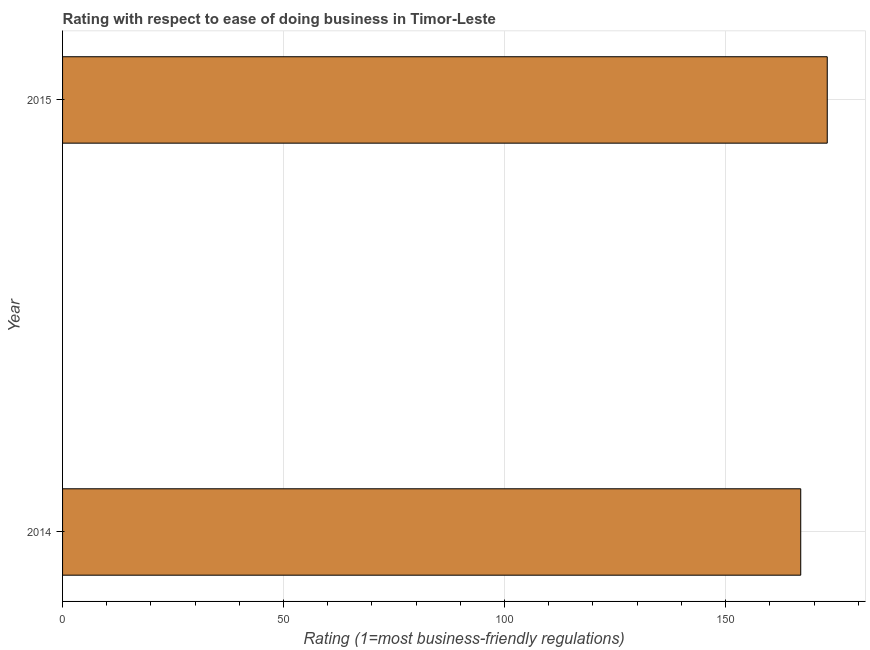Does the graph contain any zero values?
Offer a very short reply. No. Does the graph contain grids?
Give a very brief answer. Yes. What is the title of the graph?
Your response must be concise. Rating with respect to ease of doing business in Timor-Leste. What is the label or title of the X-axis?
Your answer should be very brief. Rating (1=most business-friendly regulations). What is the label or title of the Y-axis?
Your answer should be compact. Year. What is the ease of doing business index in 2014?
Offer a very short reply. 167. Across all years, what is the maximum ease of doing business index?
Offer a very short reply. 173. Across all years, what is the minimum ease of doing business index?
Provide a succinct answer. 167. In which year was the ease of doing business index maximum?
Provide a succinct answer. 2015. In which year was the ease of doing business index minimum?
Give a very brief answer. 2014. What is the sum of the ease of doing business index?
Offer a terse response. 340. What is the difference between the ease of doing business index in 2014 and 2015?
Make the answer very short. -6. What is the average ease of doing business index per year?
Provide a short and direct response. 170. What is the median ease of doing business index?
Offer a very short reply. 170. In how many years, is the ease of doing business index greater than 170 ?
Your response must be concise. 1. What is the ratio of the ease of doing business index in 2014 to that in 2015?
Provide a succinct answer. 0.96. In how many years, is the ease of doing business index greater than the average ease of doing business index taken over all years?
Give a very brief answer. 1. Are all the bars in the graph horizontal?
Offer a terse response. Yes. How many years are there in the graph?
Offer a terse response. 2. What is the Rating (1=most business-friendly regulations) in 2014?
Provide a succinct answer. 167. What is the Rating (1=most business-friendly regulations) in 2015?
Offer a very short reply. 173. What is the ratio of the Rating (1=most business-friendly regulations) in 2014 to that in 2015?
Provide a short and direct response. 0.96. 